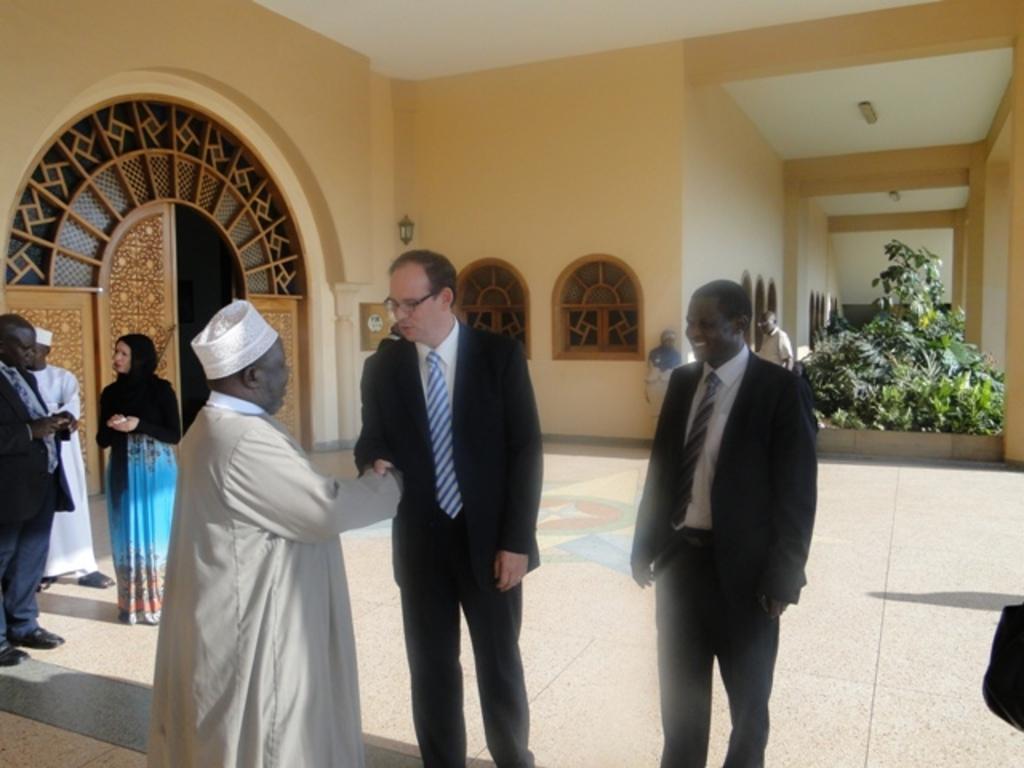Could you give a brief overview of what you see in this image? In front of the image there are two people standing and shaking hands with each other, behind them there are a few people standing, behind them there is a wooden door, glass windows and a lamp on the wall. On the right side of the image there are plants. At the top of the image on the rooftop there are lamps. 